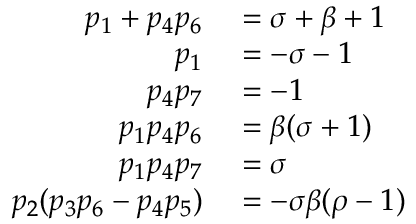Convert formula to latex. <formula><loc_0><loc_0><loc_500><loc_500>\begin{array} { r l } { p _ { 1 } + p _ { 4 } p _ { 6 } } & = \sigma + \beta + 1 } \\ { p _ { 1 } } & = - \sigma - 1 } \\ { p _ { 4 } p _ { 7 } } & = - 1 } \\ { p _ { 1 } p _ { 4 } p _ { 6 } } & = \beta ( \sigma + 1 ) } \\ { p _ { 1 } p _ { 4 } p _ { 7 } } & = \sigma } \\ { p _ { 2 } ( p _ { 3 } p _ { 6 } - p _ { 4 } p _ { 5 } ) } & = - \sigma \beta ( \rho - 1 ) } \end{array}</formula> 